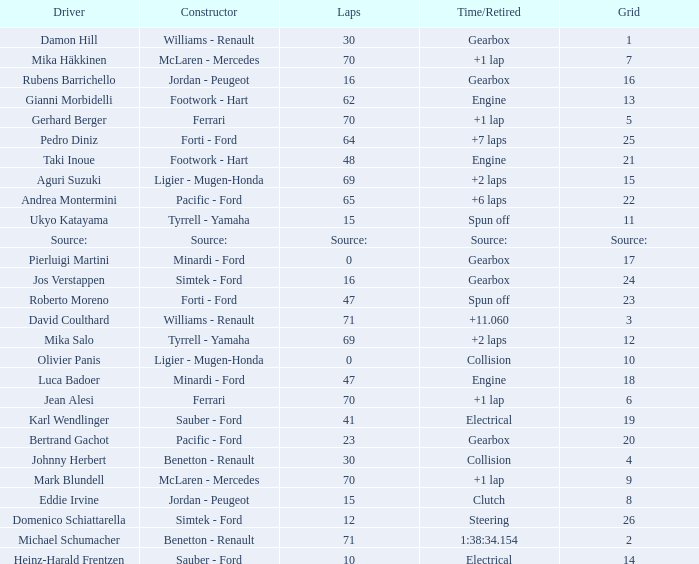David Coulthard was the driver in which grid? 3.0. 